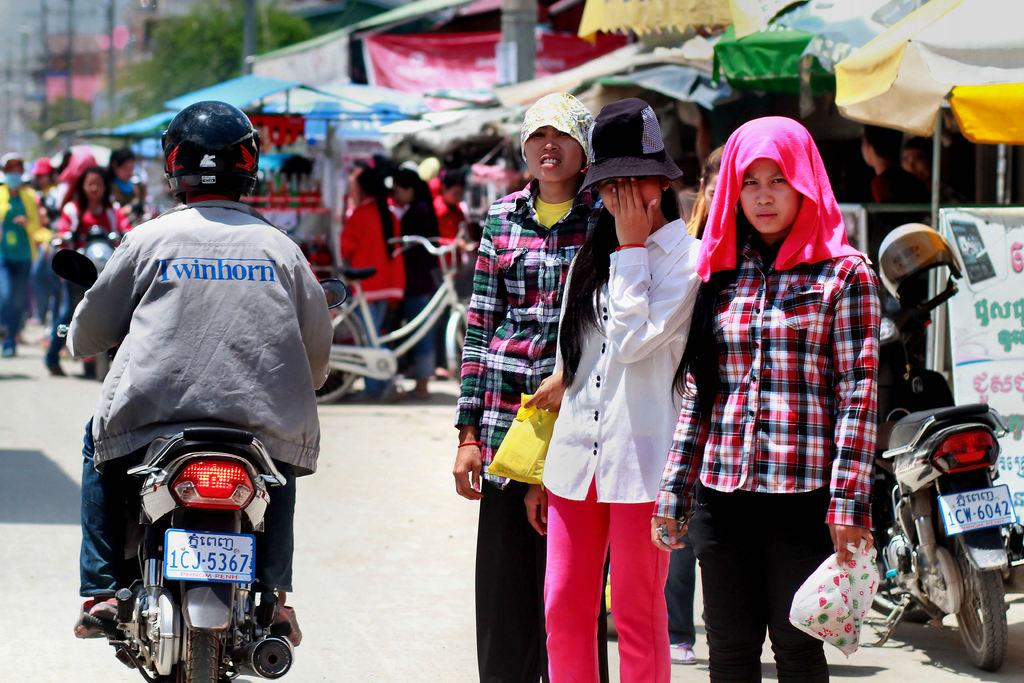What is the main subject of the image? The main subject of the image is a man riding a motorcycle. Where is the man located in the image? The man is on the left side of the image. What else can be seen on the right side of the image? There are three women standing on the right side of the image. Can you describe the background of the image? There are people visible in the background of the image. What is the tax rate on the calculator in the image? There is no calculator or tax rate mentioned in the image; it features a man riding a motorcycle and three women standing nearby. 